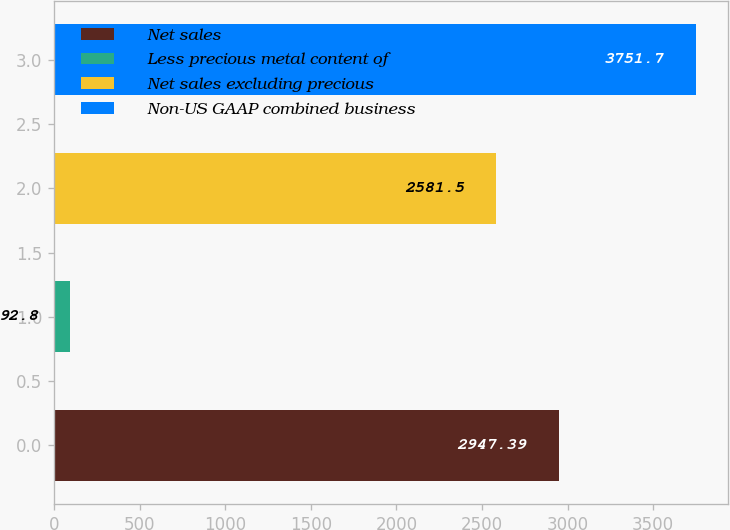<chart> <loc_0><loc_0><loc_500><loc_500><bar_chart><fcel>Net sales<fcel>Less precious metal content of<fcel>Net sales excluding precious<fcel>Non-US GAAP combined business<nl><fcel>2947.39<fcel>92.8<fcel>2581.5<fcel>3751.7<nl></chart> 